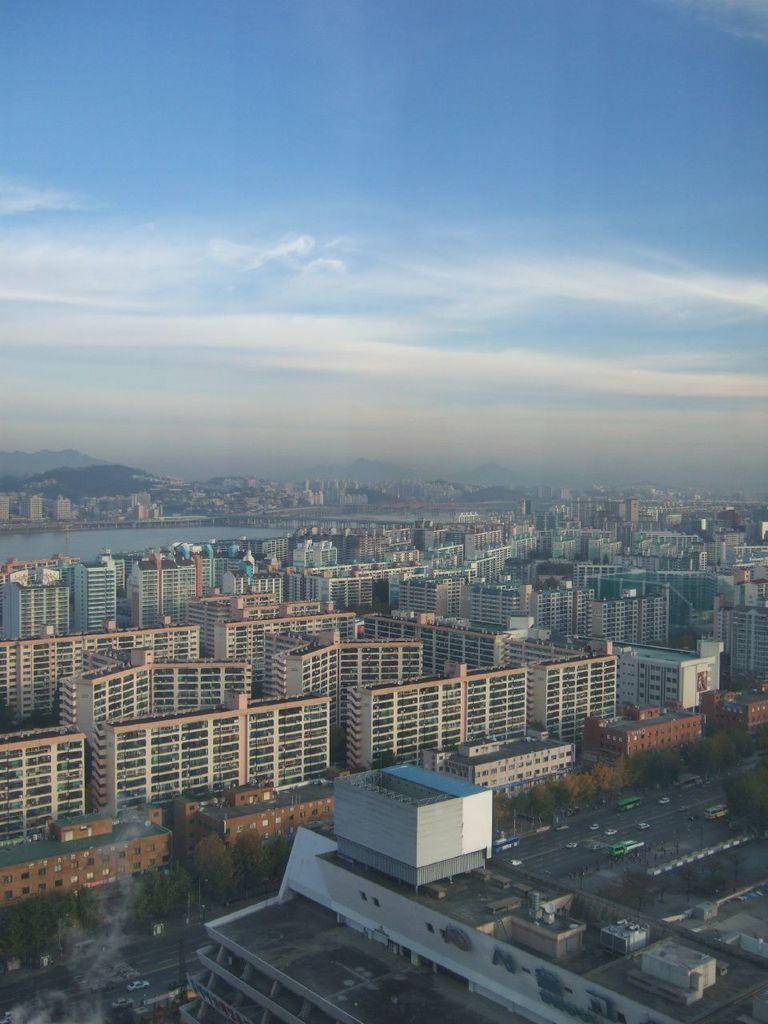In one or two sentences, can you explain what this image depicts? In this picture we can see there are buildings, trees, lake and some vehicles on the road. Behind the vehicles there are hills and the sky. 